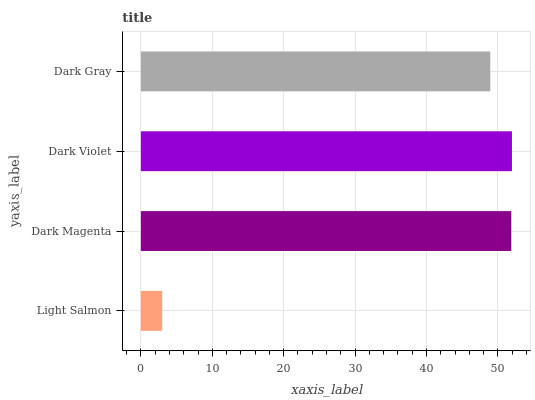Is Light Salmon the minimum?
Answer yes or no. Yes. Is Dark Violet the maximum?
Answer yes or no. Yes. Is Dark Magenta the minimum?
Answer yes or no. No. Is Dark Magenta the maximum?
Answer yes or no. No. Is Dark Magenta greater than Light Salmon?
Answer yes or no. Yes. Is Light Salmon less than Dark Magenta?
Answer yes or no. Yes. Is Light Salmon greater than Dark Magenta?
Answer yes or no. No. Is Dark Magenta less than Light Salmon?
Answer yes or no. No. Is Dark Magenta the high median?
Answer yes or no. Yes. Is Dark Gray the low median?
Answer yes or no. Yes. Is Dark Violet the high median?
Answer yes or no. No. Is Dark Violet the low median?
Answer yes or no. No. 